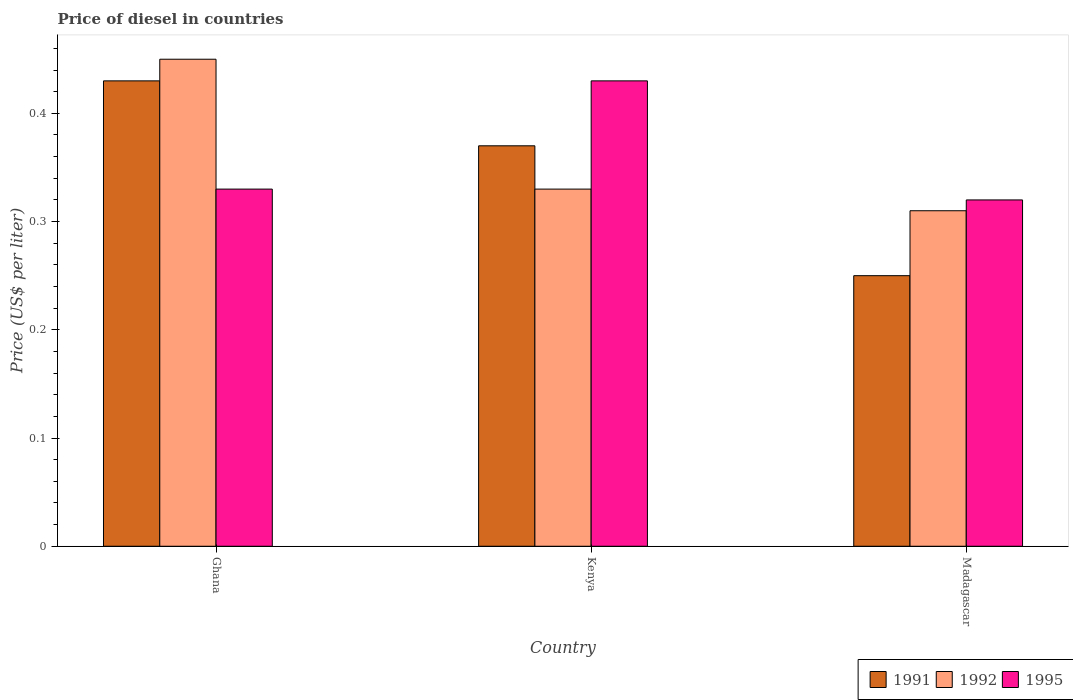How many groups of bars are there?
Give a very brief answer. 3. Are the number of bars per tick equal to the number of legend labels?
Your answer should be very brief. Yes. How many bars are there on the 3rd tick from the left?
Your answer should be very brief. 3. How many bars are there on the 1st tick from the right?
Your answer should be very brief. 3. What is the label of the 3rd group of bars from the left?
Provide a short and direct response. Madagascar. What is the price of diesel in 1991 in Kenya?
Give a very brief answer. 0.37. Across all countries, what is the maximum price of diesel in 1995?
Provide a succinct answer. 0.43. Across all countries, what is the minimum price of diesel in 1991?
Your answer should be compact. 0.25. In which country was the price of diesel in 1992 minimum?
Make the answer very short. Madagascar. What is the total price of diesel in 1992 in the graph?
Provide a succinct answer. 1.09. What is the difference between the price of diesel in 1992 in Kenya and that in Madagascar?
Your response must be concise. 0.02. What is the difference between the price of diesel in 1992 in Ghana and the price of diesel in 1991 in Madagascar?
Provide a succinct answer. 0.2. What is the average price of diesel in 1995 per country?
Your answer should be compact. 0.36. What is the difference between the price of diesel of/in 1991 and price of diesel of/in 1992 in Madagascar?
Make the answer very short. -0.06. What is the ratio of the price of diesel in 1995 in Ghana to that in Madagascar?
Offer a terse response. 1.03. Is the price of diesel in 1992 in Ghana less than that in Madagascar?
Offer a terse response. No. Is the difference between the price of diesel in 1991 in Ghana and Madagascar greater than the difference between the price of diesel in 1992 in Ghana and Madagascar?
Your response must be concise. Yes. What is the difference between the highest and the second highest price of diesel in 1991?
Provide a succinct answer. 0.06. What is the difference between the highest and the lowest price of diesel in 1995?
Keep it short and to the point. 0.11. What does the 2nd bar from the right in Madagascar represents?
Offer a very short reply. 1992. How many legend labels are there?
Offer a terse response. 3. What is the title of the graph?
Offer a terse response. Price of diesel in countries. What is the label or title of the Y-axis?
Your answer should be very brief. Price (US$ per liter). What is the Price (US$ per liter) in 1991 in Ghana?
Offer a terse response. 0.43. What is the Price (US$ per liter) of 1992 in Ghana?
Keep it short and to the point. 0.45. What is the Price (US$ per liter) of 1995 in Ghana?
Your answer should be compact. 0.33. What is the Price (US$ per liter) of 1991 in Kenya?
Your answer should be compact. 0.37. What is the Price (US$ per liter) in 1992 in Kenya?
Your answer should be compact. 0.33. What is the Price (US$ per liter) in 1995 in Kenya?
Keep it short and to the point. 0.43. What is the Price (US$ per liter) in 1992 in Madagascar?
Make the answer very short. 0.31. What is the Price (US$ per liter) in 1995 in Madagascar?
Keep it short and to the point. 0.32. Across all countries, what is the maximum Price (US$ per liter) of 1991?
Ensure brevity in your answer.  0.43. Across all countries, what is the maximum Price (US$ per liter) of 1992?
Give a very brief answer. 0.45. Across all countries, what is the maximum Price (US$ per liter) of 1995?
Provide a short and direct response. 0.43. Across all countries, what is the minimum Price (US$ per liter) of 1992?
Provide a short and direct response. 0.31. Across all countries, what is the minimum Price (US$ per liter) of 1995?
Provide a short and direct response. 0.32. What is the total Price (US$ per liter) in 1992 in the graph?
Your answer should be very brief. 1.09. What is the total Price (US$ per liter) in 1995 in the graph?
Ensure brevity in your answer.  1.08. What is the difference between the Price (US$ per liter) in 1992 in Ghana and that in Kenya?
Make the answer very short. 0.12. What is the difference between the Price (US$ per liter) of 1991 in Ghana and that in Madagascar?
Your answer should be compact. 0.18. What is the difference between the Price (US$ per liter) in 1992 in Ghana and that in Madagascar?
Give a very brief answer. 0.14. What is the difference between the Price (US$ per liter) in 1995 in Ghana and that in Madagascar?
Offer a very short reply. 0.01. What is the difference between the Price (US$ per liter) in 1991 in Kenya and that in Madagascar?
Your answer should be very brief. 0.12. What is the difference between the Price (US$ per liter) of 1992 in Kenya and that in Madagascar?
Provide a succinct answer. 0.02. What is the difference between the Price (US$ per liter) of 1995 in Kenya and that in Madagascar?
Make the answer very short. 0.11. What is the difference between the Price (US$ per liter) in 1991 in Ghana and the Price (US$ per liter) in 1992 in Kenya?
Ensure brevity in your answer.  0.1. What is the difference between the Price (US$ per liter) in 1991 in Ghana and the Price (US$ per liter) in 1995 in Kenya?
Offer a very short reply. 0. What is the difference between the Price (US$ per liter) of 1992 in Ghana and the Price (US$ per liter) of 1995 in Kenya?
Keep it short and to the point. 0.02. What is the difference between the Price (US$ per liter) of 1991 in Ghana and the Price (US$ per liter) of 1992 in Madagascar?
Keep it short and to the point. 0.12. What is the difference between the Price (US$ per liter) of 1991 in Ghana and the Price (US$ per liter) of 1995 in Madagascar?
Keep it short and to the point. 0.11. What is the difference between the Price (US$ per liter) in 1992 in Ghana and the Price (US$ per liter) in 1995 in Madagascar?
Your answer should be very brief. 0.13. What is the average Price (US$ per liter) of 1992 per country?
Your response must be concise. 0.36. What is the average Price (US$ per liter) in 1995 per country?
Offer a terse response. 0.36. What is the difference between the Price (US$ per liter) of 1991 and Price (US$ per liter) of 1992 in Ghana?
Provide a short and direct response. -0.02. What is the difference between the Price (US$ per liter) of 1992 and Price (US$ per liter) of 1995 in Ghana?
Your answer should be compact. 0.12. What is the difference between the Price (US$ per liter) of 1991 and Price (US$ per liter) of 1992 in Kenya?
Your answer should be compact. 0.04. What is the difference between the Price (US$ per liter) of 1991 and Price (US$ per liter) of 1995 in Kenya?
Keep it short and to the point. -0.06. What is the difference between the Price (US$ per liter) in 1991 and Price (US$ per liter) in 1992 in Madagascar?
Provide a short and direct response. -0.06. What is the difference between the Price (US$ per liter) of 1991 and Price (US$ per liter) of 1995 in Madagascar?
Keep it short and to the point. -0.07. What is the difference between the Price (US$ per liter) in 1992 and Price (US$ per liter) in 1995 in Madagascar?
Your response must be concise. -0.01. What is the ratio of the Price (US$ per liter) of 1991 in Ghana to that in Kenya?
Provide a succinct answer. 1.16. What is the ratio of the Price (US$ per liter) in 1992 in Ghana to that in Kenya?
Provide a succinct answer. 1.36. What is the ratio of the Price (US$ per liter) in 1995 in Ghana to that in Kenya?
Make the answer very short. 0.77. What is the ratio of the Price (US$ per liter) of 1991 in Ghana to that in Madagascar?
Offer a terse response. 1.72. What is the ratio of the Price (US$ per liter) of 1992 in Ghana to that in Madagascar?
Give a very brief answer. 1.45. What is the ratio of the Price (US$ per liter) of 1995 in Ghana to that in Madagascar?
Offer a terse response. 1.03. What is the ratio of the Price (US$ per liter) of 1991 in Kenya to that in Madagascar?
Provide a short and direct response. 1.48. What is the ratio of the Price (US$ per liter) in 1992 in Kenya to that in Madagascar?
Keep it short and to the point. 1.06. What is the ratio of the Price (US$ per liter) in 1995 in Kenya to that in Madagascar?
Make the answer very short. 1.34. What is the difference between the highest and the second highest Price (US$ per liter) in 1991?
Provide a succinct answer. 0.06. What is the difference between the highest and the second highest Price (US$ per liter) in 1992?
Ensure brevity in your answer.  0.12. What is the difference between the highest and the lowest Price (US$ per liter) in 1991?
Provide a succinct answer. 0.18. What is the difference between the highest and the lowest Price (US$ per liter) of 1992?
Make the answer very short. 0.14. What is the difference between the highest and the lowest Price (US$ per liter) in 1995?
Your answer should be compact. 0.11. 